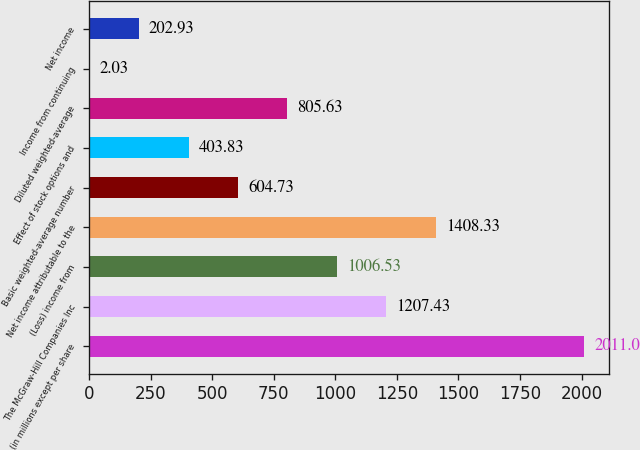Convert chart to OTSL. <chart><loc_0><loc_0><loc_500><loc_500><bar_chart><fcel>(in millions except per share<fcel>The McGraw-Hill Companies Inc<fcel>(Loss) income from<fcel>Net income attributable to the<fcel>Basic weighted-average number<fcel>Effect of stock options and<fcel>Diluted weighted-average<fcel>Income from continuing<fcel>Net income<nl><fcel>2011<fcel>1207.43<fcel>1006.53<fcel>1408.33<fcel>604.73<fcel>403.83<fcel>805.63<fcel>2.03<fcel>202.93<nl></chart> 